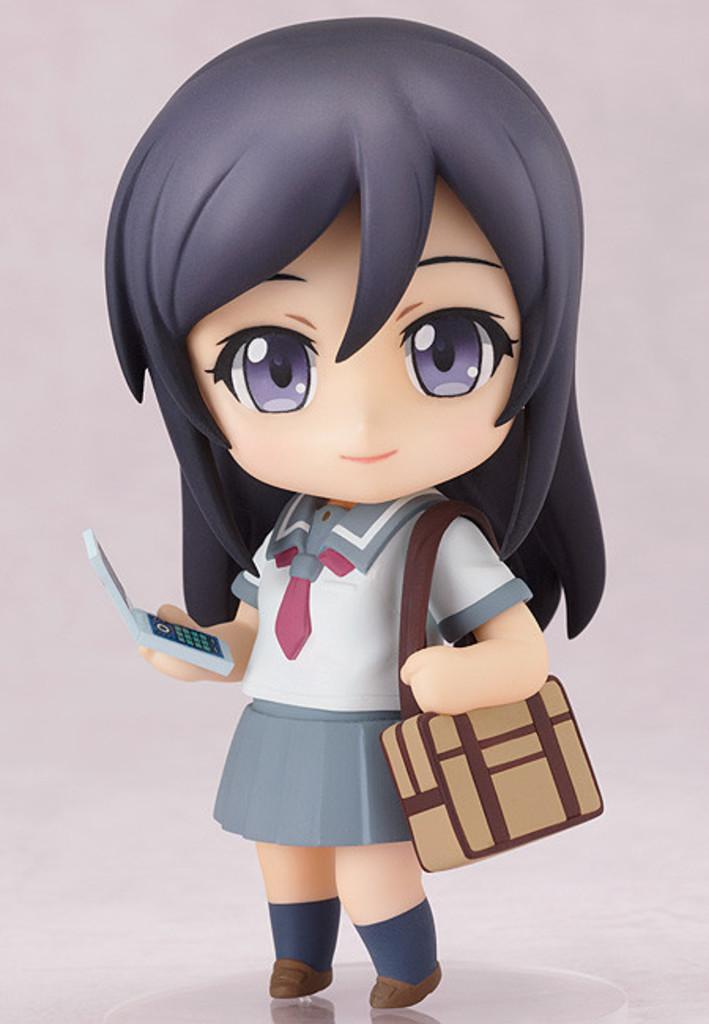What is the main subject of the image? There is a person depicted in the image. What color is the background of the image? The background of the image is pink. What is the person wearing in the image? The person is wearing a bag. What object is the person holding in the image? The person is holding a phone in her hand. What instrument is the person playing in the image? There is no instrument present in the image; the person is holding a phone. What invention is the person using to increase productivity in the image? There is no mention of an invention or productivity in the image; the person is simply holding a phone. 